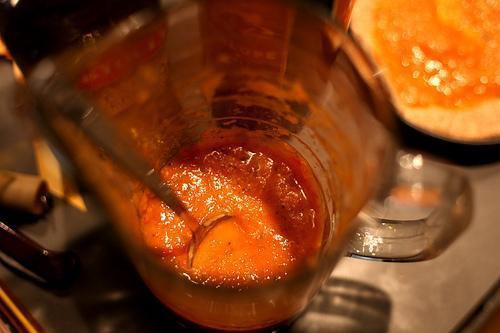How many utensils are in the photo?
Give a very brief answer. 1. How many handles are on the glass?
Give a very brief answer. 1. How many other objects are on the countertop?
Give a very brief answer. 3. How many glass mugs are on the table?
Give a very brief answer. 1. 